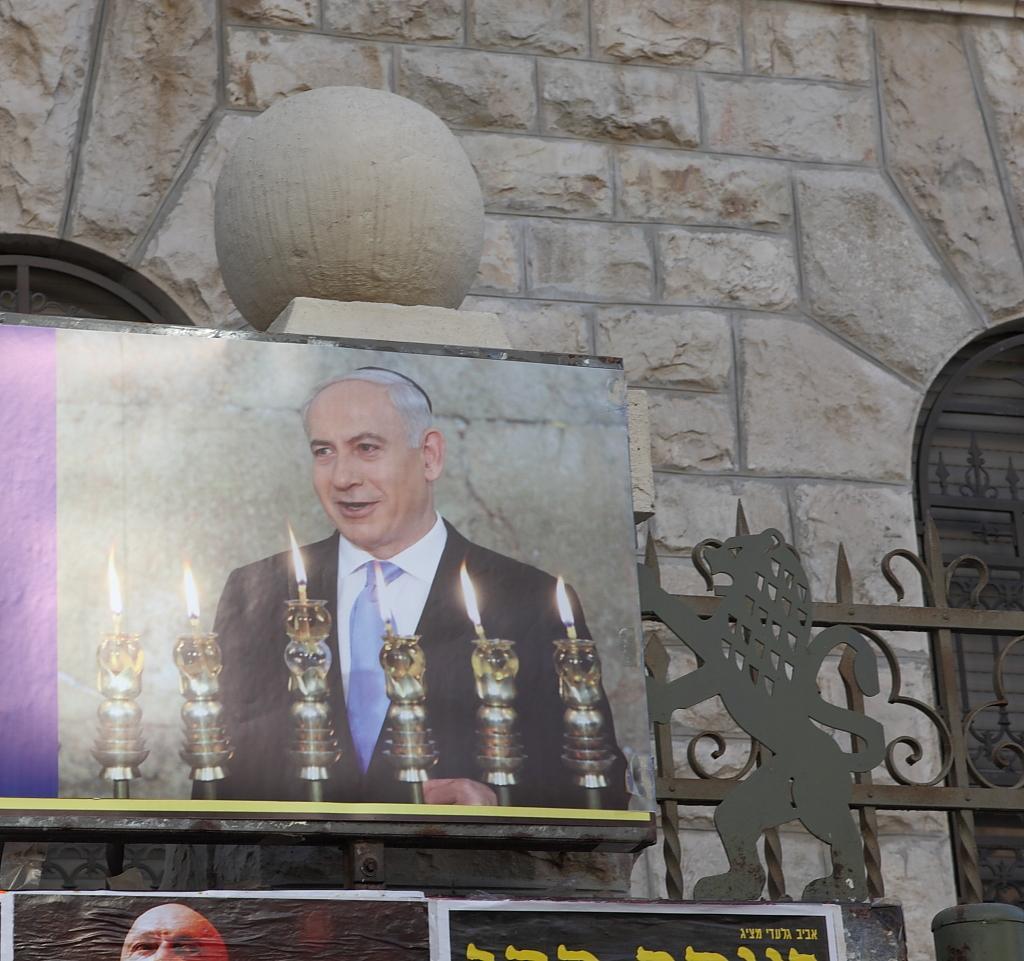Describe this image in one or two sentences. This is the photo frame of the man. I can see the candles in the candle stand, which are in front of the man. This looks like an iron grill. I think these are the posters. This is the building wall. I think here is the window. 